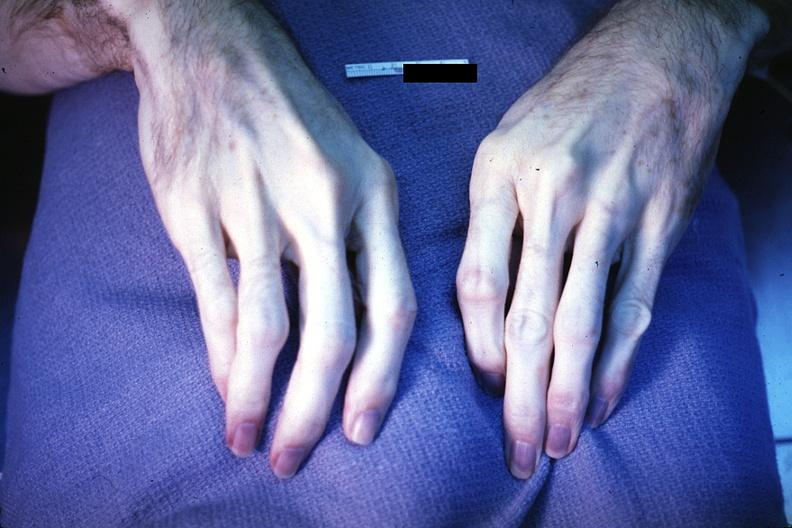s hand present?
Answer the question using a single word or phrase. Yes 